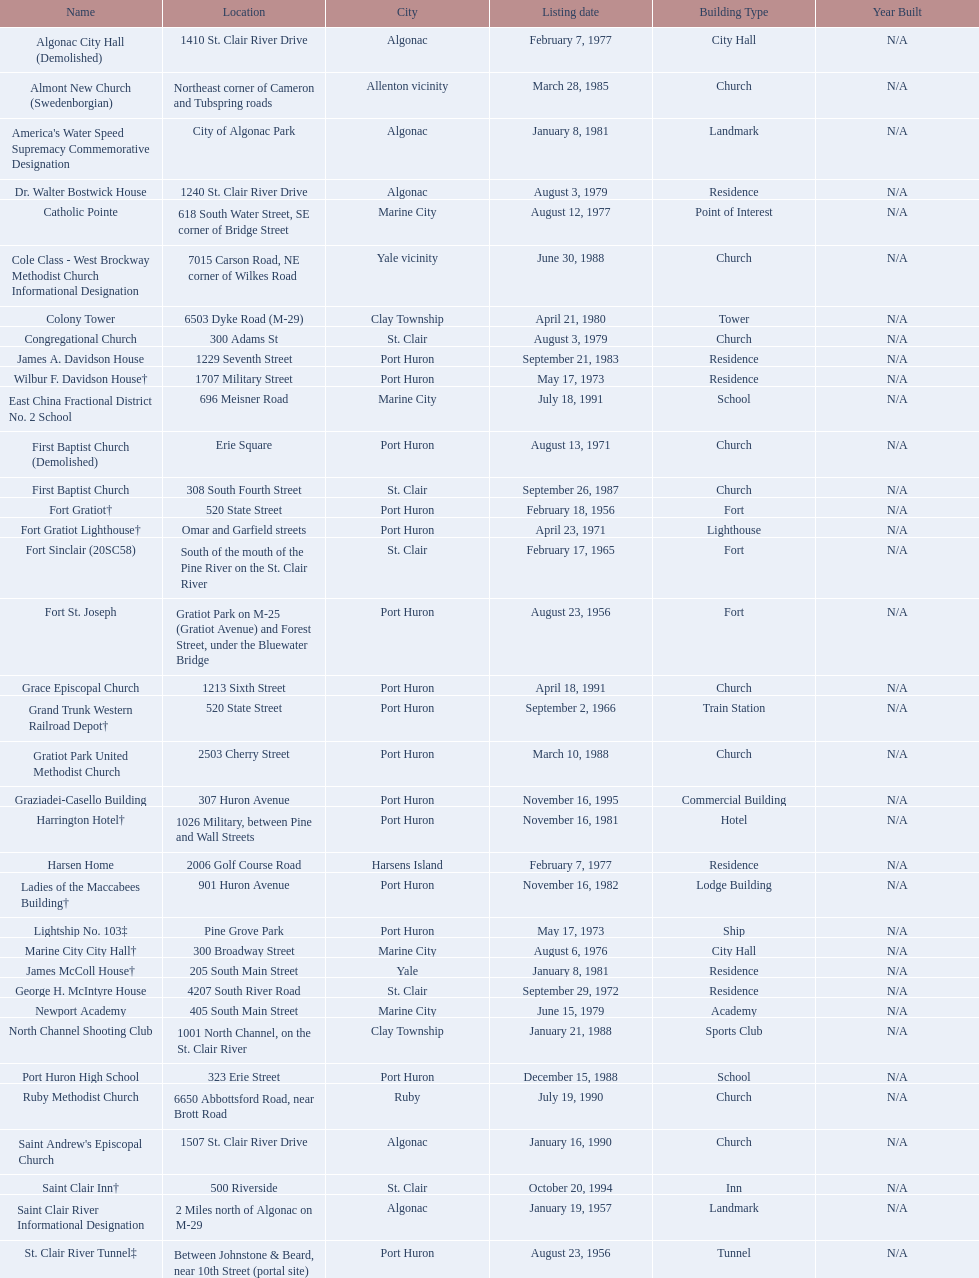How many names do not have images next to them? 41. 